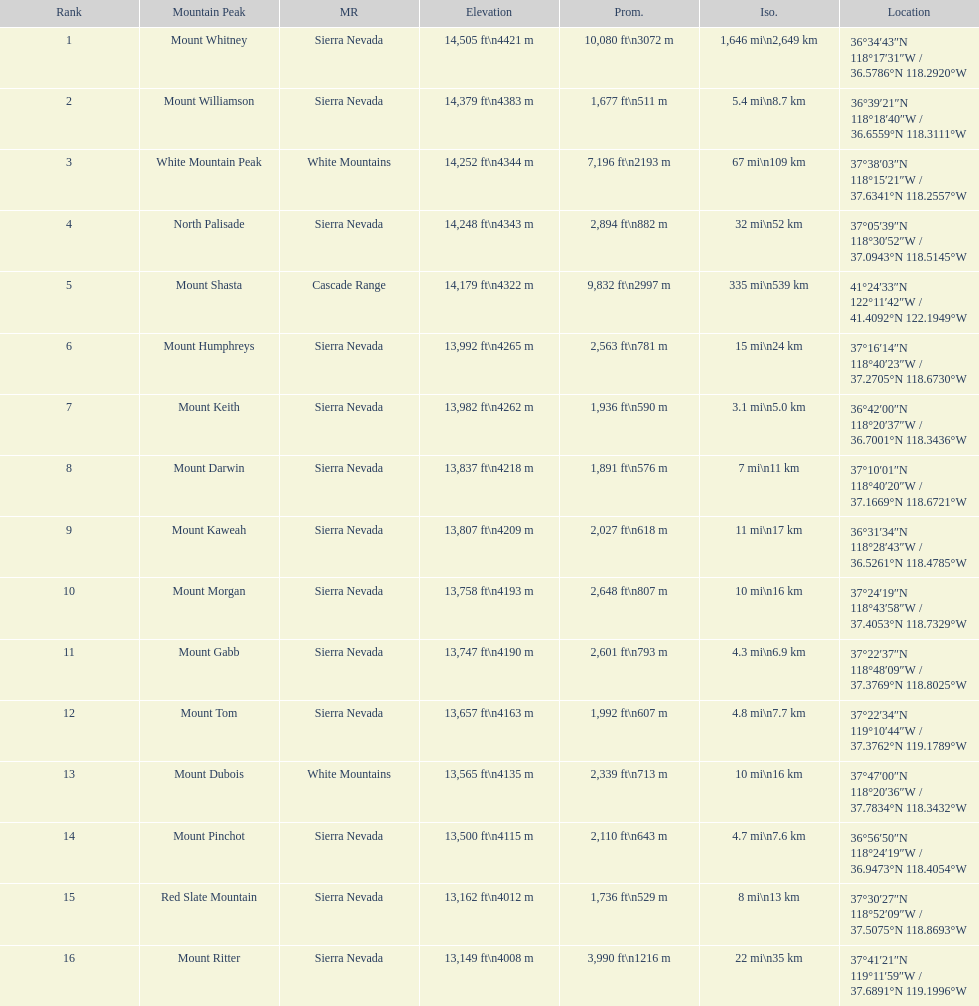Is the peak of mount keith above or below the peak of north palisade? Below. 